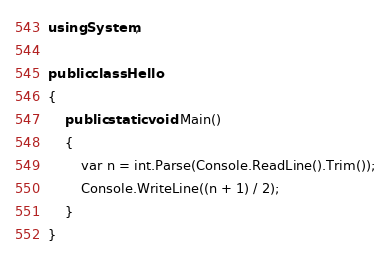Convert code to text. <code><loc_0><loc_0><loc_500><loc_500><_C#_>using System;

public class Hello
{
    public static void Main()
    {
        var n = int.Parse(Console.ReadLine().Trim());
        Console.WriteLine((n + 1) / 2);
    }
}
</code> 